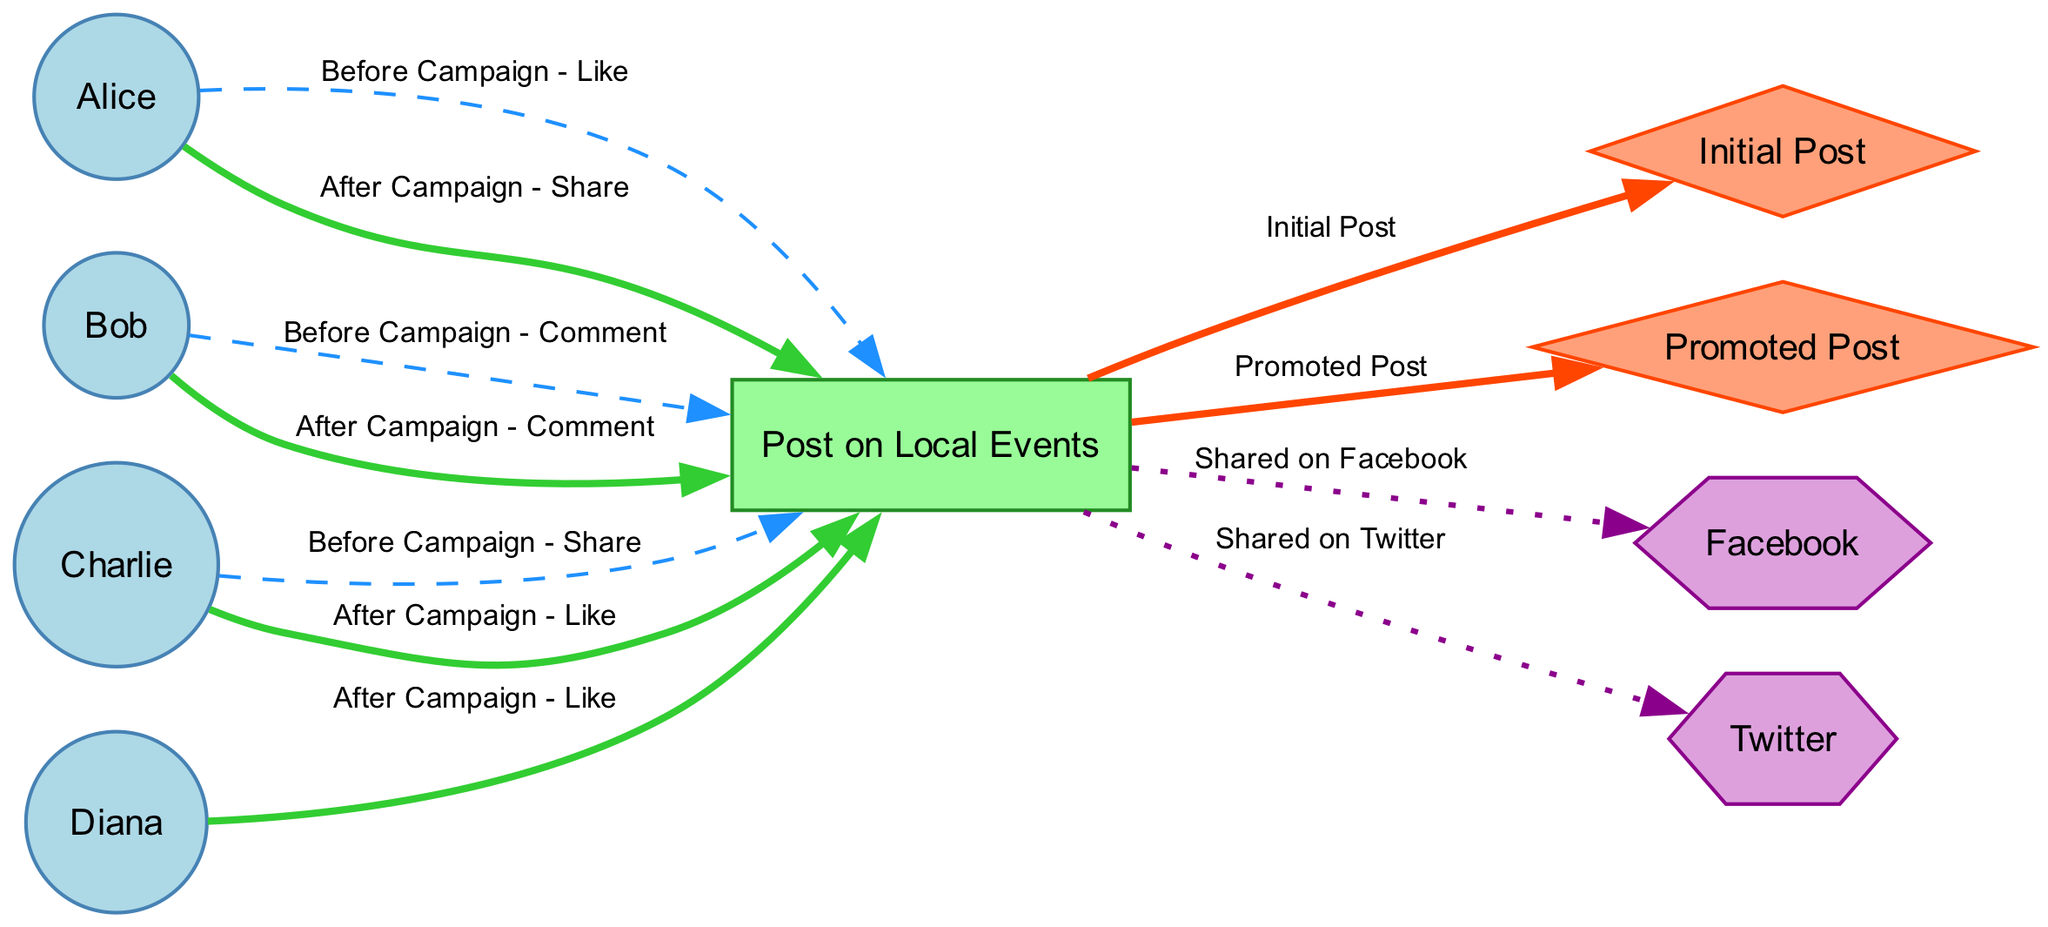What is the total number of nodes in the diagram? The diagram lists nine distinct nodes: four users, one post, two campaigns, and two platforms. By counting all the nodes mentioned in the data, we arrive at the total.
Answer: 9 Which user liked the post after the campaign? By examining the edges related to user interactions highlighted as "After Campaign," we can see that Diana liked the post. This is the specific edge connecting User4 to Post1 labeled "After Campaign - Like."
Answer: Diana How many edges represent interactions before the campaign? The edges labeled "Before Campaign" are specifically linked to the interactions Users had with the post prior to its promotion. There are three such edges: one Like from Alice, one Comment from Bob, and one Share from Charlie. Counting these gives us the total number of interactions before the campaign.
Answer: 3 What type of node represents 'Post on Local Events'? When identifying the type of the node labeled "Post on Local Events," we see it is categorized as a post based on its characteristics in the diagram where posts are represented by rectangles.
Answer: Rectangle Which campaign appears first in the interaction flow? In the diagram, the edge indicating the "Initial Post" shows a direct connection leading from the post to the first campaign, showing that it is the primary starting point of engagement. Therefore, we identify Campaign1 as being the first campaign.
Answer: Initial Post After the campaign, who commented on the post? By looking at the interactions following the campaign and focusing specifically on the edge connecting User2 with Post1, we find the action labeled "After Campaign - Comment." Thus Bob is the user who commented after the campaign.
Answer: Bob How many users liked the post after the campaign? By going through the edges stemming from users to the post and filtering for actions labeled "After Campaign - Like," we find two users—Diana and Charlie—interacted this way, providing us the total count.
Answer: 2 What is the visual distinction of edges representing interactions after the campaign? The edges representing interactions after the campaign are thicker, indicated by a pen width of 2.0, and are colored green, providing a clear visual differentiation from the dashed blue edges that represent interactions before the campaign.
Answer: Thicker and green What do the hexagon nodes represent in the diagram? The nodes shaped as hexagons in the diagram correspond to platforms, distinguishing them visually from other types of nodes like users and posts. Thus, the hexagons here represent social media platforms.
Answer: Platforms 